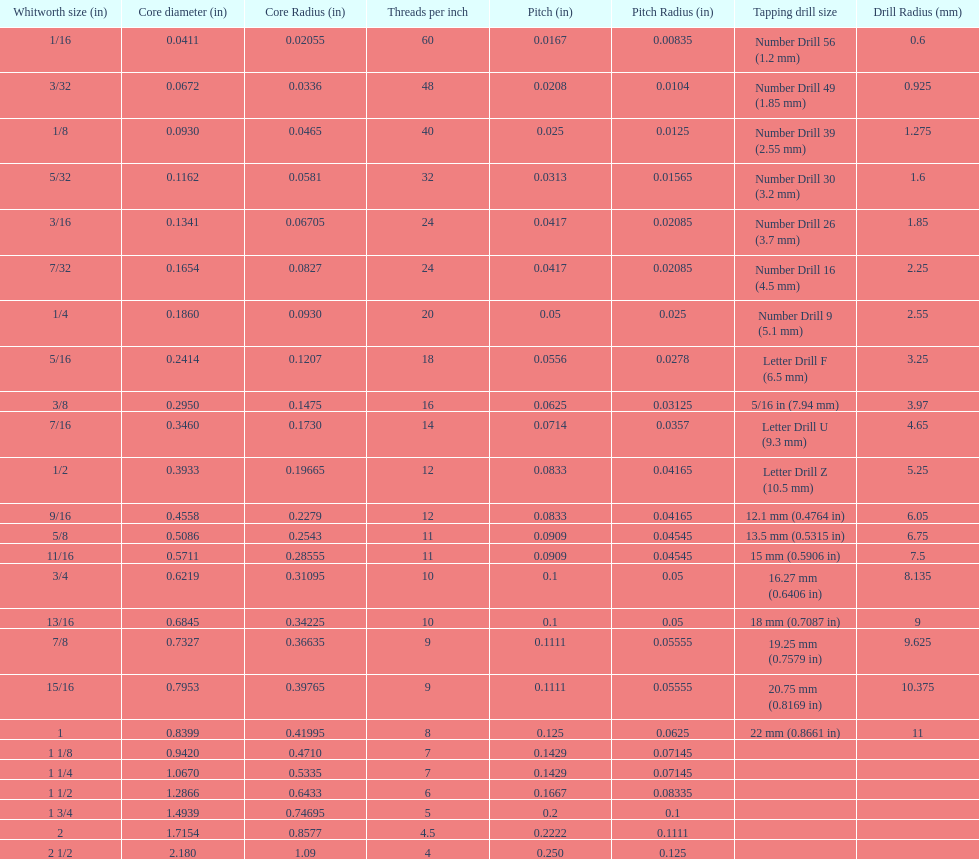What is the central diameter of the final whitworth thread size? 2.180. 